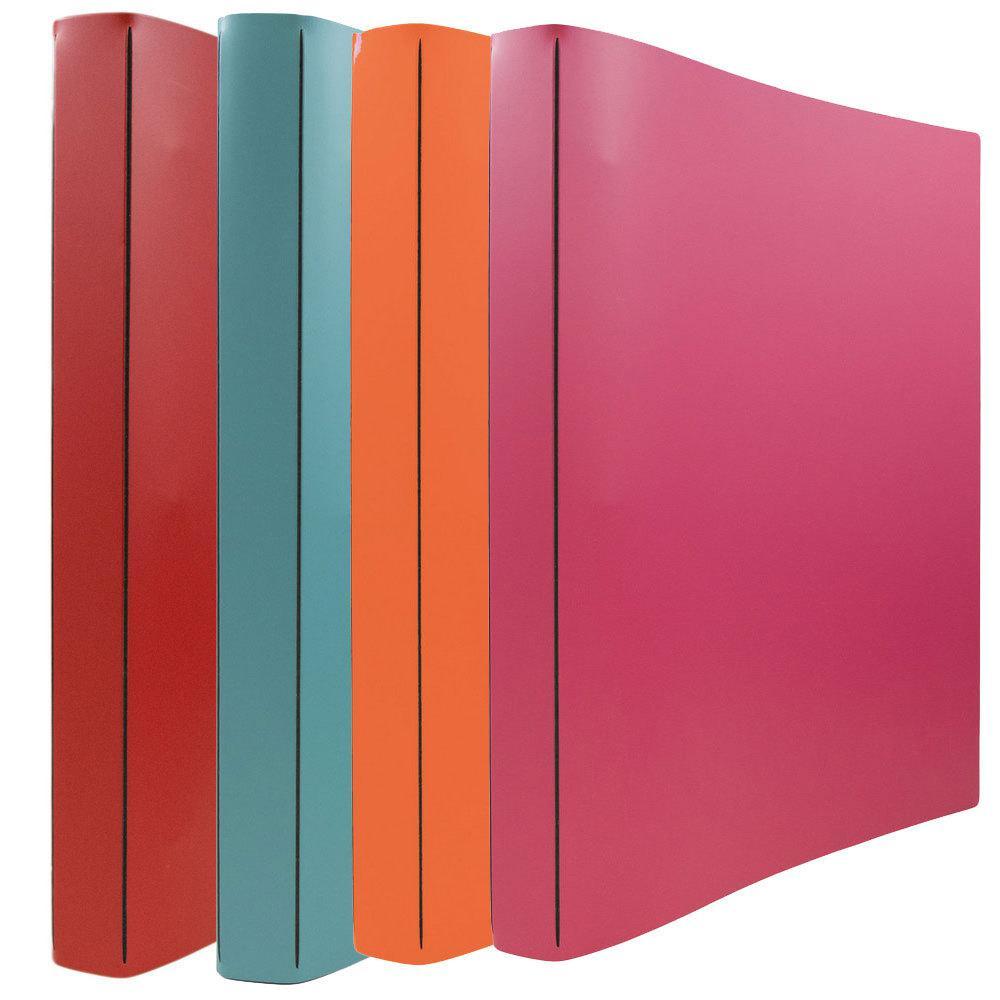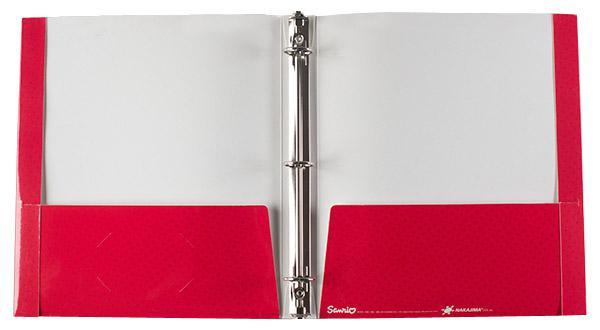The first image is the image on the left, the second image is the image on the right. Examine the images to the left and right. Is the description "There are fewer than four binders in total." accurate? Answer yes or no. No. The first image is the image on the left, the second image is the image on the right. Evaluate the accuracy of this statement regarding the images: "The left image contains at least two binders.". Is it true? Answer yes or no. Yes. 